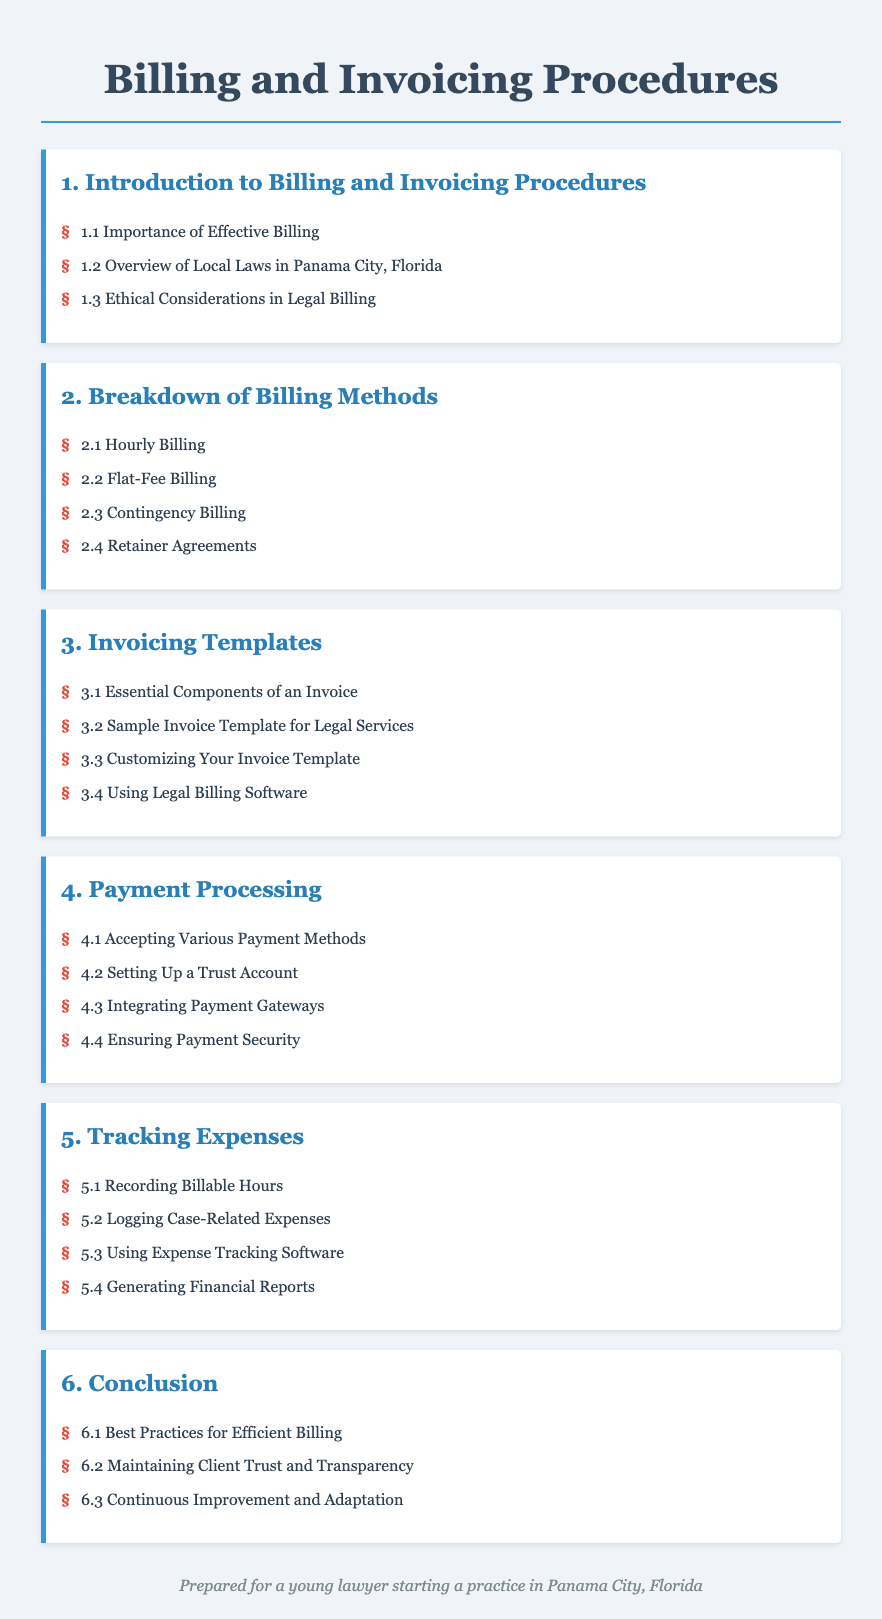what is the first chapter title? The first chapter title in the document is "Introduction to Billing and Invoicing Procedures."
Answer: Introduction to Billing and Invoicing Procedures how many billing methods are listed? The document lists four billing methods in the "Breakdown of Billing Methods" chapter.
Answer: 4 what is the sample invoice template related to? The document specifies that the second item in the "Invoicing Templates" chapter is a sample for legal services.
Answer: Legal Services which component is essential in an invoice? The first item in the "Invoicing Templates" chapter mentions essential components of an invoice.
Answer: Essential Components of an Invoice what chapter discusses payment processing? The chapter that addresses payment processing is titled "Payment Processing."
Answer: Payment Processing which billing method is based on a percentage of the awarded amount? The term describing this billing method can be found in the "Breakdown of Billing Methods" chapter and pertains to outcomes-based charges.
Answer: Contingency Billing what best practice is suggested in the conclusion? The document emphasizes efficient billing as a best practice in the "Conclusion."
Answer: Best Practices for Efficient Billing how many sections are in the "Tracking Expenses" chapter? The "Tracking Expenses" chapter contains four sections.
Answer: 4 which section advises on maintaining client trust? The last section in the "Conclusion" chapter suggests ways to maintain client trust.
Answer: Maintaining Client Trust and Transparency 